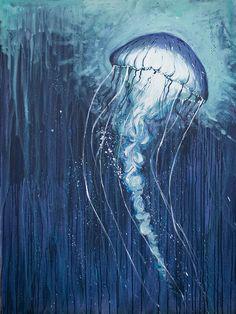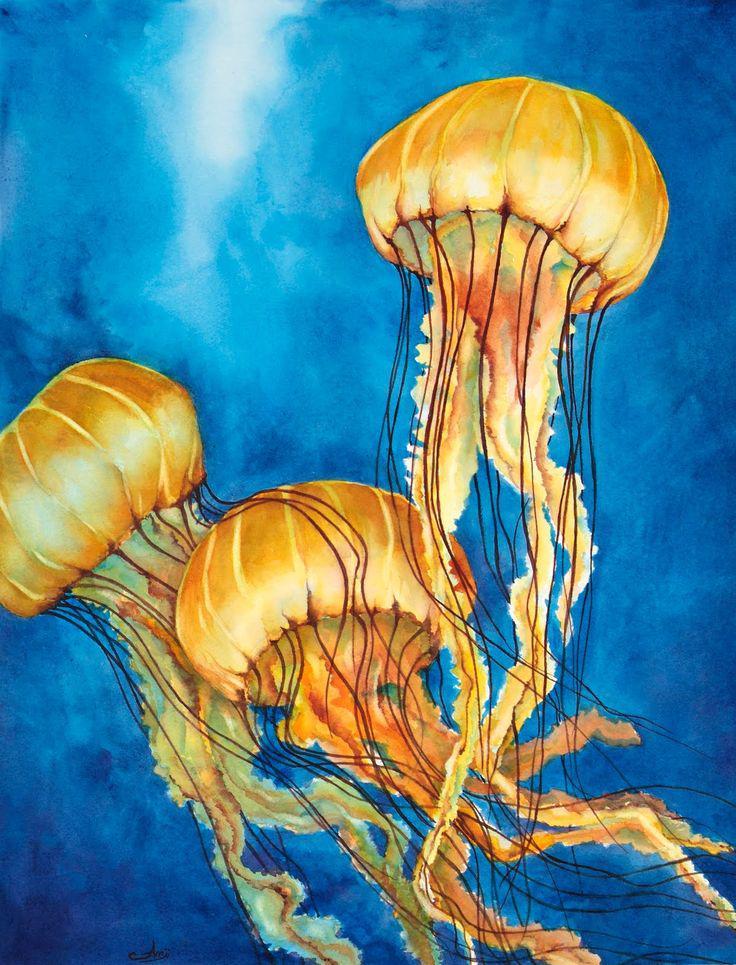The first image is the image on the left, the second image is the image on the right. Evaluate the accuracy of this statement regarding the images: "A person is painting a picture of jellyfish in one of the images.". Is it true? Answer yes or no. No. The first image is the image on the left, the second image is the image on the right. Evaluate the accuracy of this statement regarding the images: "An image shows a hand at the right painting a jellyfish scene.". Is it true? Answer yes or no. No. 